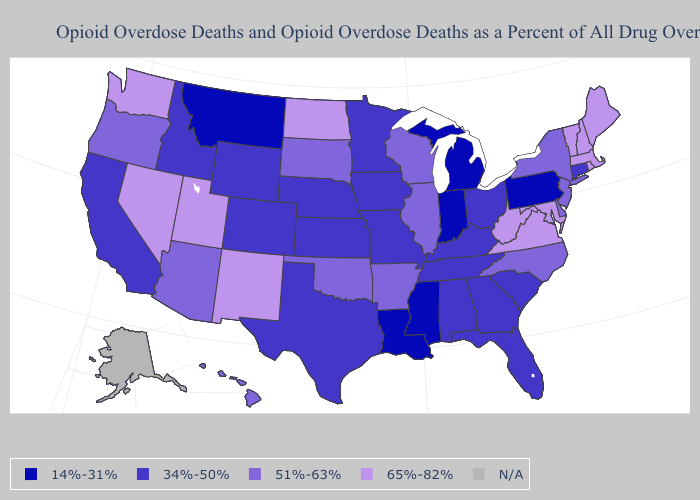Among the states that border Texas , which have the highest value?
Concise answer only. New Mexico. What is the value of Iowa?
Give a very brief answer. 34%-50%. Does Idaho have the lowest value in the USA?
Write a very short answer. No. What is the value of Georgia?
Short answer required. 34%-50%. Name the states that have a value in the range 14%-31%?
Keep it brief. Indiana, Louisiana, Michigan, Mississippi, Montana, Pennsylvania. Does Utah have the highest value in the West?
Keep it brief. Yes. Among the states that border Virginia , does Tennessee have the lowest value?
Write a very short answer. Yes. Name the states that have a value in the range 14%-31%?
Be succinct. Indiana, Louisiana, Michigan, Mississippi, Montana, Pennsylvania. Name the states that have a value in the range N/A?
Short answer required. Alaska. What is the highest value in the USA?
Answer briefly. 65%-82%. What is the value of Kansas?
Be succinct. 34%-50%. Does the map have missing data?
Answer briefly. Yes. Name the states that have a value in the range N/A?
Concise answer only. Alaska. 